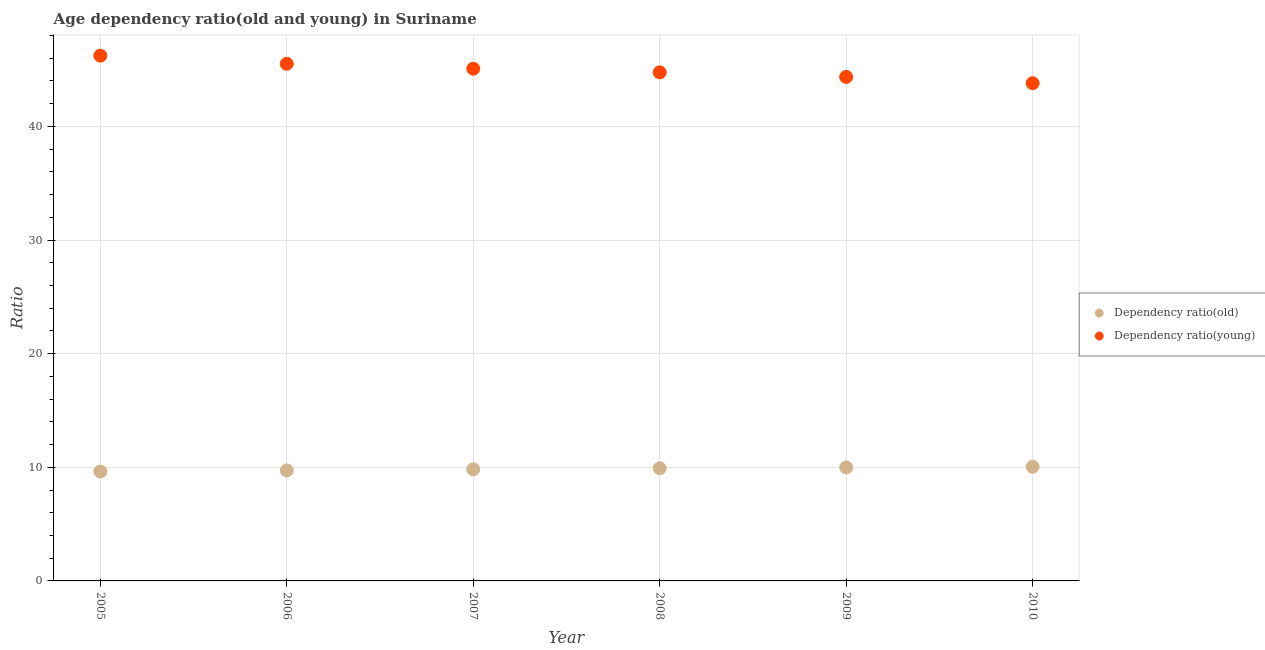What is the age dependency ratio(young) in 2005?
Make the answer very short. 46.22. Across all years, what is the maximum age dependency ratio(old)?
Provide a short and direct response. 10.04. Across all years, what is the minimum age dependency ratio(young)?
Your answer should be compact. 43.8. In which year was the age dependency ratio(old) maximum?
Give a very brief answer. 2010. In which year was the age dependency ratio(young) minimum?
Your response must be concise. 2010. What is the total age dependency ratio(old) in the graph?
Provide a short and direct response. 59.12. What is the difference between the age dependency ratio(old) in 2008 and that in 2010?
Your answer should be very brief. -0.13. What is the difference between the age dependency ratio(young) in 2007 and the age dependency ratio(old) in 2006?
Offer a very short reply. 35.35. What is the average age dependency ratio(young) per year?
Give a very brief answer. 44.95. In the year 2006, what is the difference between the age dependency ratio(old) and age dependency ratio(young)?
Give a very brief answer. -35.78. In how many years, is the age dependency ratio(old) greater than 14?
Keep it short and to the point. 0. What is the ratio of the age dependency ratio(old) in 2009 to that in 2010?
Provide a short and direct response. 0.99. What is the difference between the highest and the second highest age dependency ratio(young)?
Keep it short and to the point. 0.71. What is the difference between the highest and the lowest age dependency ratio(old)?
Provide a succinct answer. 0.42. Is the sum of the age dependency ratio(old) in 2006 and 2010 greater than the maximum age dependency ratio(young) across all years?
Your answer should be very brief. No. Is the age dependency ratio(old) strictly less than the age dependency ratio(young) over the years?
Give a very brief answer. Yes. How many dotlines are there?
Offer a terse response. 2. How many years are there in the graph?
Ensure brevity in your answer.  6. Does the graph contain any zero values?
Ensure brevity in your answer.  No. Does the graph contain grids?
Provide a succinct answer. Yes. Where does the legend appear in the graph?
Give a very brief answer. Center right. What is the title of the graph?
Keep it short and to the point. Age dependency ratio(old and young) in Suriname. Does "Nitrous oxide emissions" appear as one of the legend labels in the graph?
Ensure brevity in your answer.  No. What is the label or title of the X-axis?
Provide a succinct answer. Year. What is the label or title of the Y-axis?
Your answer should be compact. Ratio. What is the Ratio in Dependency ratio(old) in 2005?
Provide a short and direct response. 9.62. What is the Ratio in Dependency ratio(young) in 2005?
Make the answer very short. 46.22. What is the Ratio of Dependency ratio(old) in 2006?
Ensure brevity in your answer.  9.73. What is the Ratio of Dependency ratio(young) in 2006?
Your answer should be compact. 45.51. What is the Ratio in Dependency ratio(old) in 2007?
Make the answer very short. 9.82. What is the Ratio in Dependency ratio(young) in 2007?
Keep it short and to the point. 45.08. What is the Ratio in Dependency ratio(old) in 2008?
Make the answer very short. 9.91. What is the Ratio in Dependency ratio(young) in 2008?
Keep it short and to the point. 44.75. What is the Ratio in Dependency ratio(old) in 2009?
Provide a succinct answer. 9.99. What is the Ratio of Dependency ratio(young) in 2009?
Provide a short and direct response. 44.35. What is the Ratio of Dependency ratio(old) in 2010?
Keep it short and to the point. 10.04. What is the Ratio in Dependency ratio(young) in 2010?
Ensure brevity in your answer.  43.8. Across all years, what is the maximum Ratio in Dependency ratio(old)?
Your answer should be very brief. 10.04. Across all years, what is the maximum Ratio in Dependency ratio(young)?
Your answer should be compact. 46.22. Across all years, what is the minimum Ratio in Dependency ratio(old)?
Make the answer very short. 9.62. Across all years, what is the minimum Ratio of Dependency ratio(young)?
Offer a very short reply. 43.8. What is the total Ratio in Dependency ratio(old) in the graph?
Ensure brevity in your answer.  59.12. What is the total Ratio in Dependency ratio(young) in the graph?
Keep it short and to the point. 269.72. What is the difference between the Ratio in Dependency ratio(old) in 2005 and that in 2006?
Offer a very short reply. -0.1. What is the difference between the Ratio of Dependency ratio(young) in 2005 and that in 2006?
Your response must be concise. 0.71. What is the difference between the Ratio in Dependency ratio(old) in 2005 and that in 2007?
Provide a succinct answer. -0.2. What is the difference between the Ratio of Dependency ratio(young) in 2005 and that in 2007?
Provide a succinct answer. 1.15. What is the difference between the Ratio in Dependency ratio(old) in 2005 and that in 2008?
Your answer should be very brief. -0.29. What is the difference between the Ratio in Dependency ratio(young) in 2005 and that in 2008?
Make the answer very short. 1.47. What is the difference between the Ratio of Dependency ratio(old) in 2005 and that in 2009?
Provide a short and direct response. -0.36. What is the difference between the Ratio in Dependency ratio(young) in 2005 and that in 2009?
Provide a short and direct response. 1.87. What is the difference between the Ratio of Dependency ratio(old) in 2005 and that in 2010?
Your answer should be compact. -0.42. What is the difference between the Ratio of Dependency ratio(young) in 2005 and that in 2010?
Offer a terse response. 2.42. What is the difference between the Ratio of Dependency ratio(old) in 2006 and that in 2007?
Give a very brief answer. -0.1. What is the difference between the Ratio in Dependency ratio(young) in 2006 and that in 2007?
Give a very brief answer. 0.43. What is the difference between the Ratio of Dependency ratio(old) in 2006 and that in 2008?
Ensure brevity in your answer.  -0.19. What is the difference between the Ratio in Dependency ratio(young) in 2006 and that in 2008?
Your answer should be compact. 0.76. What is the difference between the Ratio in Dependency ratio(old) in 2006 and that in 2009?
Your answer should be very brief. -0.26. What is the difference between the Ratio of Dependency ratio(young) in 2006 and that in 2009?
Offer a very short reply. 1.16. What is the difference between the Ratio of Dependency ratio(old) in 2006 and that in 2010?
Ensure brevity in your answer.  -0.32. What is the difference between the Ratio of Dependency ratio(young) in 2006 and that in 2010?
Offer a terse response. 1.71. What is the difference between the Ratio in Dependency ratio(old) in 2007 and that in 2008?
Ensure brevity in your answer.  -0.09. What is the difference between the Ratio of Dependency ratio(young) in 2007 and that in 2008?
Offer a terse response. 0.32. What is the difference between the Ratio of Dependency ratio(old) in 2007 and that in 2009?
Provide a short and direct response. -0.16. What is the difference between the Ratio of Dependency ratio(young) in 2007 and that in 2009?
Give a very brief answer. 0.72. What is the difference between the Ratio of Dependency ratio(old) in 2007 and that in 2010?
Your answer should be very brief. -0.22. What is the difference between the Ratio in Dependency ratio(young) in 2007 and that in 2010?
Your answer should be very brief. 1.28. What is the difference between the Ratio of Dependency ratio(old) in 2008 and that in 2009?
Provide a succinct answer. -0.07. What is the difference between the Ratio of Dependency ratio(young) in 2008 and that in 2009?
Provide a succinct answer. 0.4. What is the difference between the Ratio of Dependency ratio(old) in 2008 and that in 2010?
Provide a short and direct response. -0.13. What is the difference between the Ratio of Dependency ratio(young) in 2008 and that in 2010?
Offer a very short reply. 0.95. What is the difference between the Ratio of Dependency ratio(old) in 2009 and that in 2010?
Make the answer very short. -0.06. What is the difference between the Ratio in Dependency ratio(young) in 2009 and that in 2010?
Your response must be concise. 0.55. What is the difference between the Ratio of Dependency ratio(old) in 2005 and the Ratio of Dependency ratio(young) in 2006?
Give a very brief answer. -35.88. What is the difference between the Ratio of Dependency ratio(old) in 2005 and the Ratio of Dependency ratio(young) in 2007?
Ensure brevity in your answer.  -35.45. What is the difference between the Ratio in Dependency ratio(old) in 2005 and the Ratio in Dependency ratio(young) in 2008?
Your answer should be compact. -35.13. What is the difference between the Ratio of Dependency ratio(old) in 2005 and the Ratio of Dependency ratio(young) in 2009?
Make the answer very short. -34.73. What is the difference between the Ratio of Dependency ratio(old) in 2005 and the Ratio of Dependency ratio(young) in 2010?
Offer a very short reply. -34.18. What is the difference between the Ratio in Dependency ratio(old) in 2006 and the Ratio in Dependency ratio(young) in 2007?
Your response must be concise. -35.35. What is the difference between the Ratio in Dependency ratio(old) in 2006 and the Ratio in Dependency ratio(young) in 2008?
Offer a terse response. -35.03. What is the difference between the Ratio in Dependency ratio(old) in 2006 and the Ratio in Dependency ratio(young) in 2009?
Offer a very short reply. -34.63. What is the difference between the Ratio of Dependency ratio(old) in 2006 and the Ratio of Dependency ratio(young) in 2010?
Provide a short and direct response. -34.07. What is the difference between the Ratio in Dependency ratio(old) in 2007 and the Ratio in Dependency ratio(young) in 2008?
Make the answer very short. -34.93. What is the difference between the Ratio in Dependency ratio(old) in 2007 and the Ratio in Dependency ratio(young) in 2009?
Provide a short and direct response. -34.53. What is the difference between the Ratio of Dependency ratio(old) in 2007 and the Ratio of Dependency ratio(young) in 2010?
Your response must be concise. -33.98. What is the difference between the Ratio in Dependency ratio(old) in 2008 and the Ratio in Dependency ratio(young) in 2009?
Ensure brevity in your answer.  -34.44. What is the difference between the Ratio of Dependency ratio(old) in 2008 and the Ratio of Dependency ratio(young) in 2010?
Your answer should be very brief. -33.89. What is the difference between the Ratio in Dependency ratio(old) in 2009 and the Ratio in Dependency ratio(young) in 2010?
Make the answer very short. -33.81. What is the average Ratio in Dependency ratio(old) per year?
Your answer should be compact. 9.85. What is the average Ratio in Dependency ratio(young) per year?
Your answer should be compact. 44.95. In the year 2005, what is the difference between the Ratio in Dependency ratio(old) and Ratio in Dependency ratio(young)?
Give a very brief answer. -36.6. In the year 2006, what is the difference between the Ratio of Dependency ratio(old) and Ratio of Dependency ratio(young)?
Your answer should be compact. -35.78. In the year 2007, what is the difference between the Ratio of Dependency ratio(old) and Ratio of Dependency ratio(young)?
Your answer should be very brief. -35.25. In the year 2008, what is the difference between the Ratio in Dependency ratio(old) and Ratio in Dependency ratio(young)?
Make the answer very short. -34.84. In the year 2009, what is the difference between the Ratio in Dependency ratio(old) and Ratio in Dependency ratio(young)?
Your answer should be very brief. -34.37. In the year 2010, what is the difference between the Ratio of Dependency ratio(old) and Ratio of Dependency ratio(young)?
Provide a short and direct response. -33.76. What is the ratio of the Ratio of Dependency ratio(old) in 2005 to that in 2006?
Your answer should be very brief. 0.99. What is the ratio of the Ratio in Dependency ratio(young) in 2005 to that in 2006?
Make the answer very short. 1.02. What is the ratio of the Ratio of Dependency ratio(old) in 2005 to that in 2007?
Your answer should be very brief. 0.98. What is the ratio of the Ratio in Dependency ratio(young) in 2005 to that in 2007?
Provide a succinct answer. 1.03. What is the ratio of the Ratio in Dependency ratio(young) in 2005 to that in 2008?
Provide a short and direct response. 1.03. What is the ratio of the Ratio of Dependency ratio(old) in 2005 to that in 2009?
Offer a very short reply. 0.96. What is the ratio of the Ratio in Dependency ratio(young) in 2005 to that in 2009?
Your answer should be compact. 1.04. What is the ratio of the Ratio in Dependency ratio(old) in 2005 to that in 2010?
Keep it short and to the point. 0.96. What is the ratio of the Ratio of Dependency ratio(young) in 2005 to that in 2010?
Your answer should be compact. 1.06. What is the ratio of the Ratio of Dependency ratio(old) in 2006 to that in 2007?
Give a very brief answer. 0.99. What is the ratio of the Ratio in Dependency ratio(young) in 2006 to that in 2007?
Your response must be concise. 1.01. What is the ratio of the Ratio of Dependency ratio(old) in 2006 to that in 2008?
Offer a very short reply. 0.98. What is the ratio of the Ratio in Dependency ratio(young) in 2006 to that in 2008?
Give a very brief answer. 1.02. What is the ratio of the Ratio of Dependency ratio(old) in 2006 to that in 2009?
Offer a very short reply. 0.97. What is the ratio of the Ratio in Dependency ratio(old) in 2006 to that in 2010?
Offer a terse response. 0.97. What is the ratio of the Ratio in Dependency ratio(young) in 2006 to that in 2010?
Ensure brevity in your answer.  1.04. What is the ratio of the Ratio of Dependency ratio(old) in 2007 to that in 2008?
Keep it short and to the point. 0.99. What is the ratio of the Ratio of Dependency ratio(young) in 2007 to that in 2008?
Offer a terse response. 1.01. What is the ratio of the Ratio of Dependency ratio(old) in 2007 to that in 2009?
Make the answer very short. 0.98. What is the ratio of the Ratio in Dependency ratio(young) in 2007 to that in 2009?
Offer a very short reply. 1.02. What is the ratio of the Ratio in Dependency ratio(young) in 2007 to that in 2010?
Keep it short and to the point. 1.03. What is the ratio of the Ratio of Dependency ratio(old) in 2008 to that in 2009?
Offer a very short reply. 0.99. What is the ratio of the Ratio in Dependency ratio(young) in 2008 to that in 2009?
Make the answer very short. 1.01. What is the ratio of the Ratio of Dependency ratio(old) in 2008 to that in 2010?
Your answer should be very brief. 0.99. What is the ratio of the Ratio of Dependency ratio(young) in 2008 to that in 2010?
Give a very brief answer. 1.02. What is the ratio of the Ratio in Dependency ratio(young) in 2009 to that in 2010?
Your answer should be very brief. 1.01. What is the difference between the highest and the second highest Ratio in Dependency ratio(old)?
Your answer should be compact. 0.06. What is the difference between the highest and the second highest Ratio of Dependency ratio(young)?
Make the answer very short. 0.71. What is the difference between the highest and the lowest Ratio in Dependency ratio(old)?
Give a very brief answer. 0.42. What is the difference between the highest and the lowest Ratio of Dependency ratio(young)?
Your answer should be compact. 2.42. 